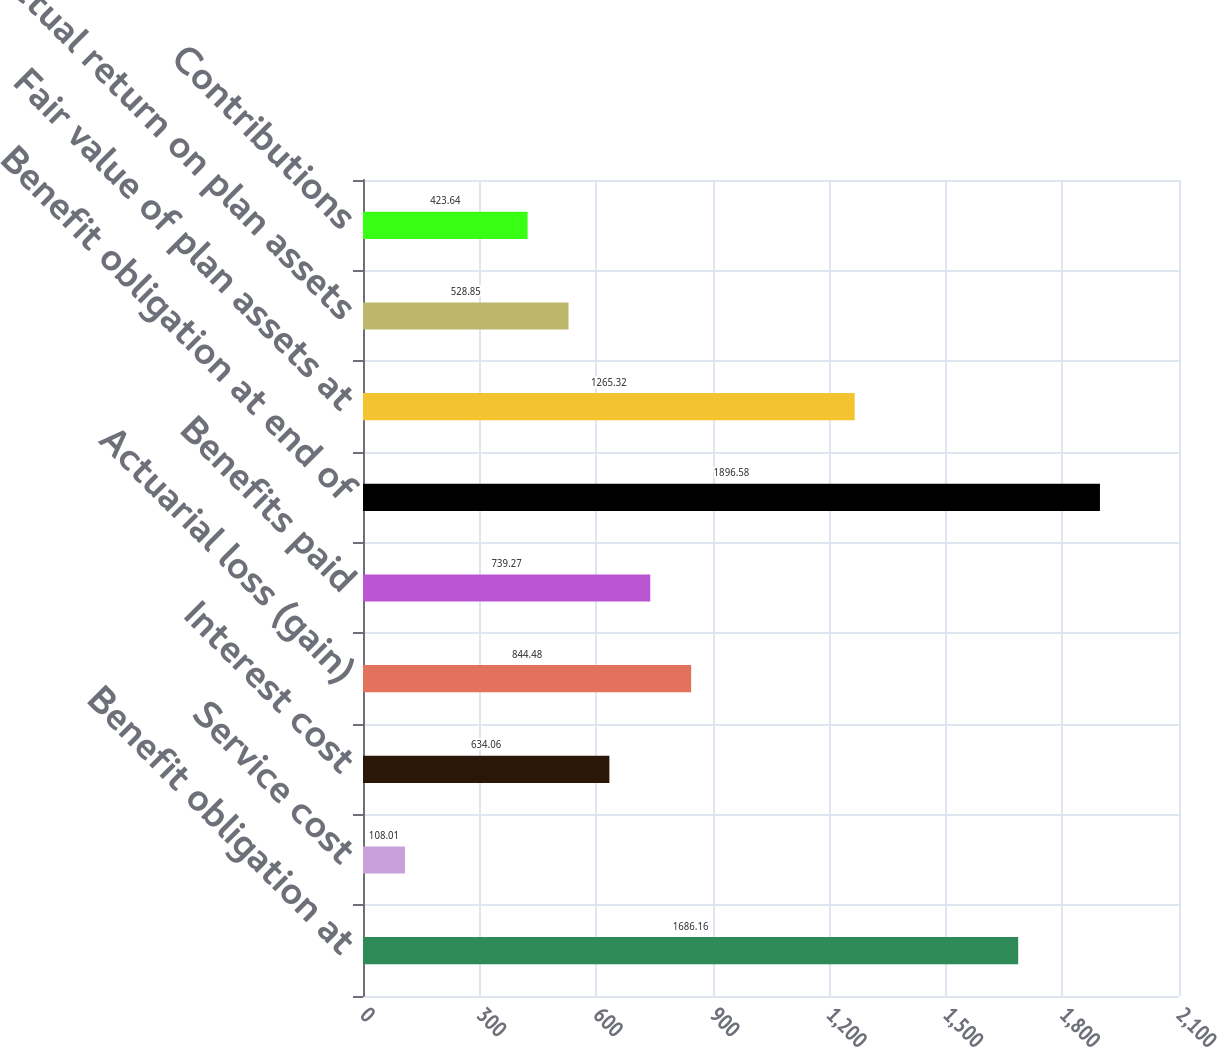<chart> <loc_0><loc_0><loc_500><loc_500><bar_chart><fcel>Benefit obligation at<fcel>Service cost<fcel>Interest cost<fcel>Actuarial loss (gain)<fcel>Benefits paid<fcel>Benefit obligation at end of<fcel>Fair value of plan assets at<fcel>Actual return on plan assets<fcel>Contributions<nl><fcel>1686.16<fcel>108.01<fcel>634.06<fcel>844.48<fcel>739.27<fcel>1896.58<fcel>1265.32<fcel>528.85<fcel>423.64<nl></chart> 